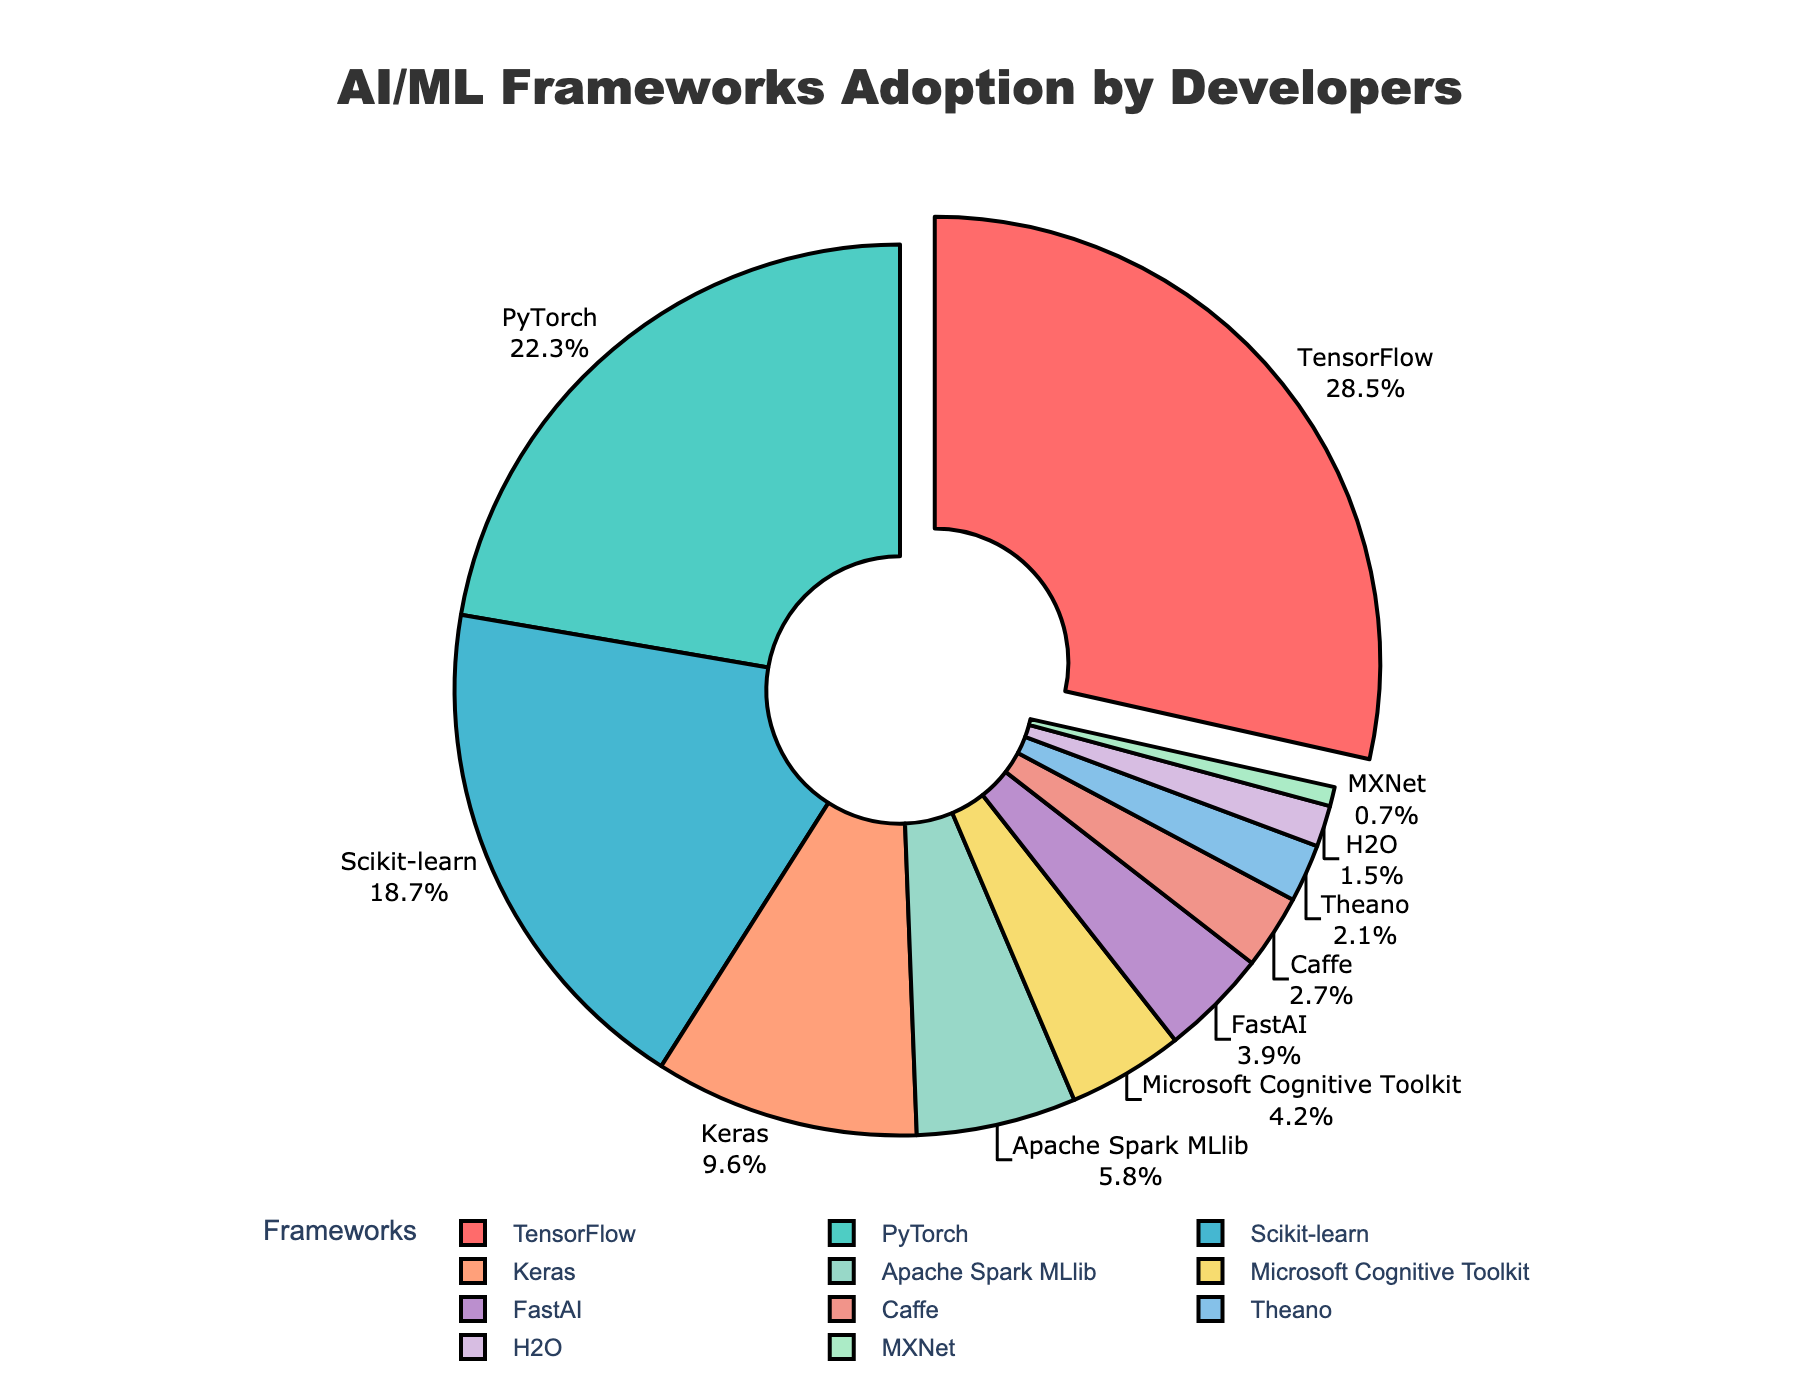Which AI/ML framework is the most adopted by developers? The largest segment on the pie chart, which is pulled out, represents TensorFlow with 28.5% adoption.
Answer: TensorFlow What is the combined adoption percentage of PyTorch and Scikit-learn? The adoption percentage of PyTorch is 22.3% and Scikit-learn is 18.7%. Adding these together, 22.3% + 18.7% = 41.0%.
Answer: 41.0% Which framework has the least adoption by developers? The smallest segment on the pie chart represents MXNet with 0.7% adoption.
Answer: MXNet How does the adoption of Keras compare to the adoption of FastAI? Keras has an adoption percentage of 9.6%, while FastAI has 3.9%. Therefore, the adoption of Keras is higher.
Answer: Keras has higher adoption What is the total adoption percentage of frameworks with more than 10% adoption? The frameworks with more than 10% adoption are TensorFlow (28.5%) and PyTorch (22.3%). The total is 28.5% + 22.3% = 50.8%.
Answer: 50.8% Which color represents Microsoft Cognitive Toolkit? The pie chart uses different colors for each segment, and the segment for Microsoft Cognitive Toolkit is represented in a shade of yellow.
Answer: Yellow Is the adoption of Apache Spark MLlib greater than twice the adoption of H2O? Apache Spark MLlib has an adoption of 5.8%, while H2O has 1.5%. Twice the adoption of H2O is 1.5% * 2 = 3%. Since 5.8% > 3%, Apache Spark MLlib's adoption is greater than twice that of H2O.
Answer: Yes What is the difference in adoption percentage between the most adopted and least adopted frameworks? The most adopted framework is TensorFlow with 28.5%, and the least adopted is MXNet with 0.7%. The difference is 28.5% - 0.7% = 27.8%.
Answer: 27.8% How many frameworks have an adoption rate below 5%? The frameworks with adoption rates below 5% are Apache Spark MLlib (5.8% is excluded), Microsoft Cognitive Toolkit (4.2%), FastAI (3.9%), Caffe (2.7%), Theano (2.1%), H2O (1.5%), and MXNet (0.7%). This makes a total of 6 frameworks.
Answer: 6 